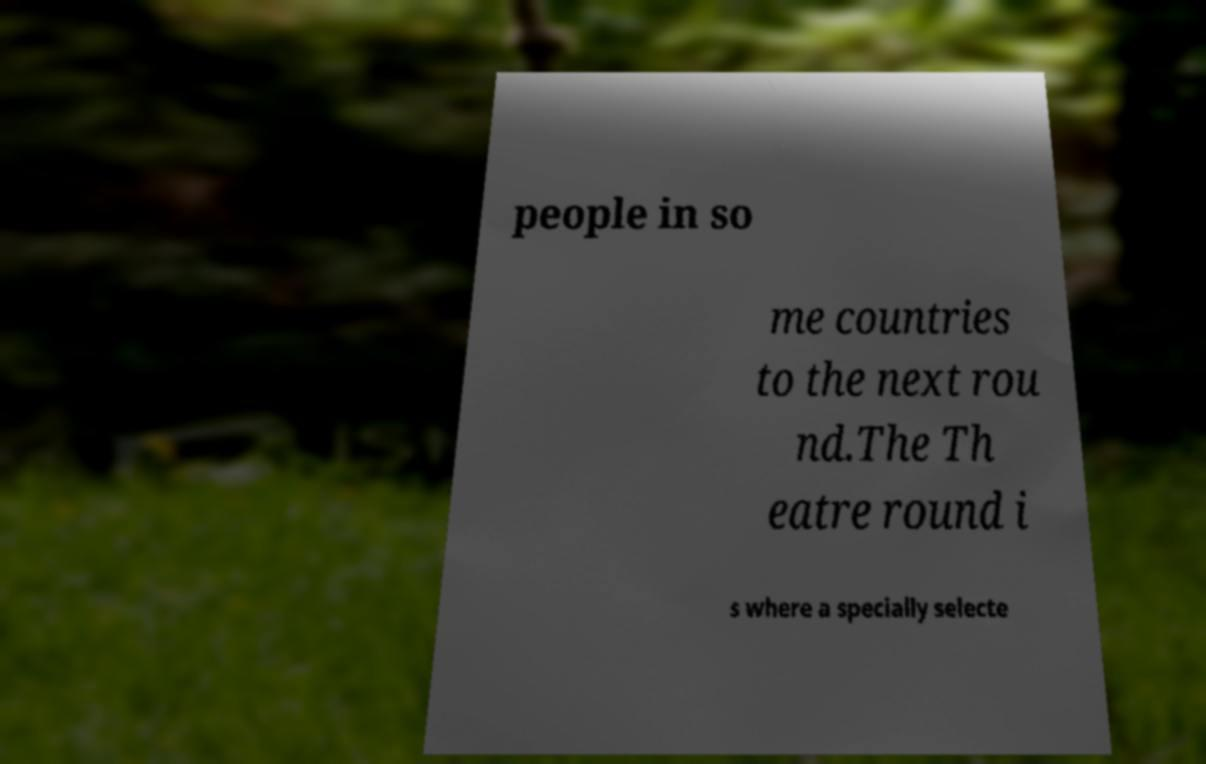I need the written content from this picture converted into text. Can you do that? people in so me countries to the next rou nd.The Th eatre round i s where a specially selecte 